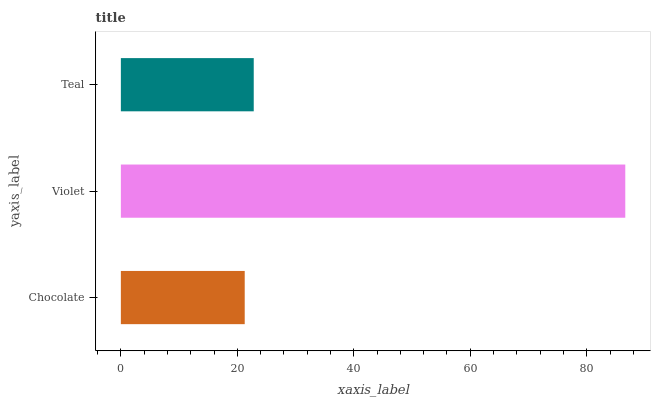Is Chocolate the minimum?
Answer yes or no. Yes. Is Violet the maximum?
Answer yes or no. Yes. Is Teal the minimum?
Answer yes or no. No. Is Teal the maximum?
Answer yes or no. No. Is Violet greater than Teal?
Answer yes or no. Yes. Is Teal less than Violet?
Answer yes or no. Yes. Is Teal greater than Violet?
Answer yes or no. No. Is Violet less than Teal?
Answer yes or no. No. Is Teal the high median?
Answer yes or no. Yes. Is Teal the low median?
Answer yes or no. Yes. Is Chocolate the high median?
Answer yes or no. No. Is Violet the low median?
Answer yes or no. No. 